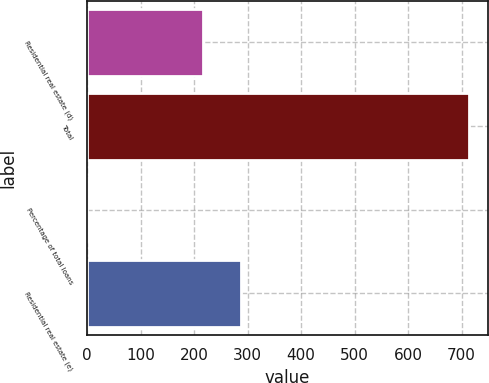<chart> <loc_0><loc_0><loc_500><loc_500><bar_chart><fcel>Residential real estate (d)<fcel>Total<fcel>Percentage of total loans<fcel>Residential real estate (e)<nl><fcel>217<fcel>714<fcel>0.37<fcel>288.36<nl></chart> 